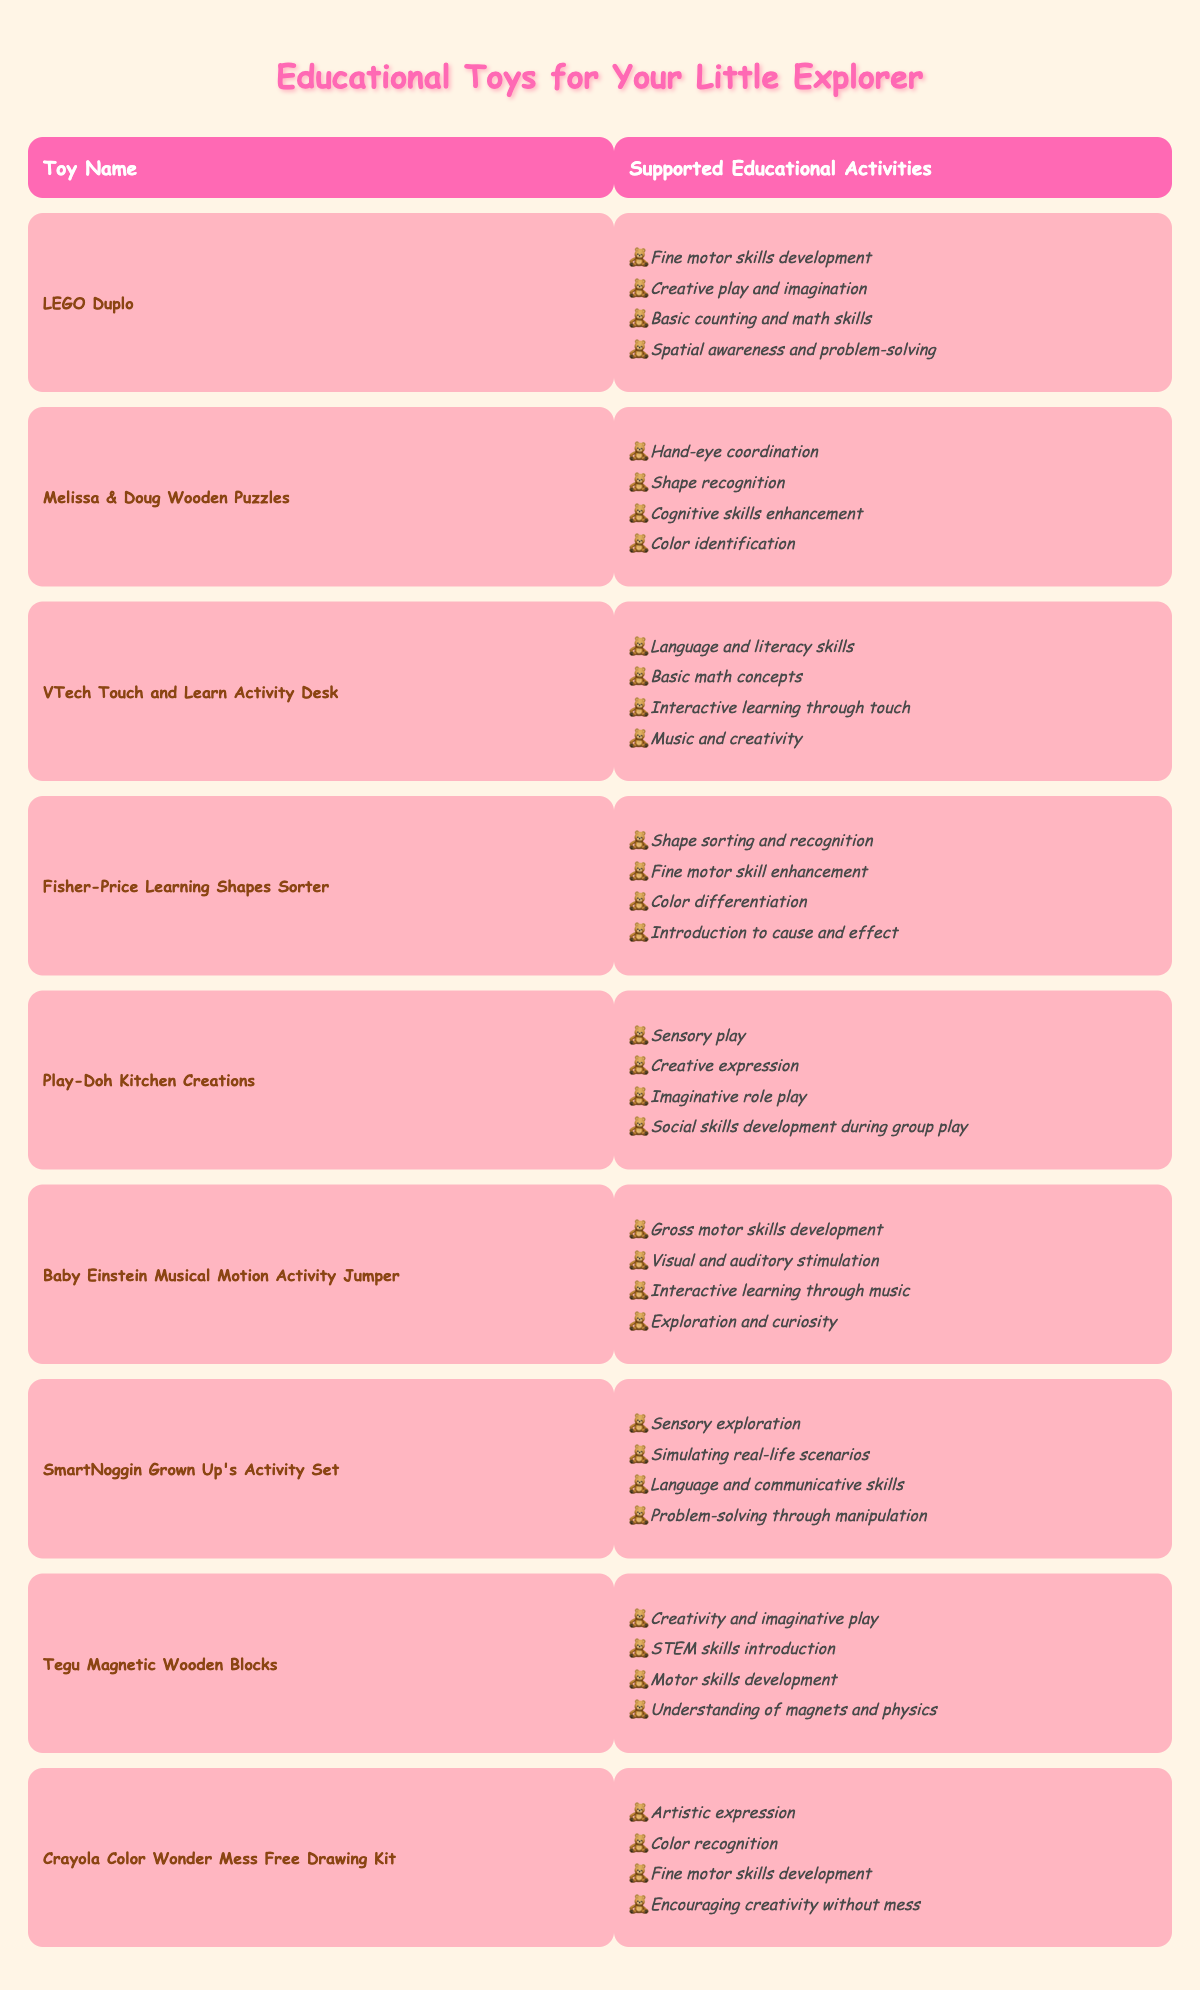What educational activity does LEGO Duplo support? LEGO Duplo supports various activities including fine motor skills development, creative play and imagination, basic counting and math skills, and spatial awareness and problem-solving. You can find these details in the supported activities section for LEGO Duplo in the table.
Answer: Fine motor skills development, creative play and imagination, basic counting and math skills, spatial awareness and problem-solving Which toy supports shape recognition? The toy that supports shape recognition is the Melissa & Doug Wooden Puzzles. This information is found in the supported activities section alongside the toy's name in the table.
Answer: Melissa & Doug Wooden Puzzles How many toys support gross motor skills development? The only toy that supports gross motor skills development is the Baby Einstein Musical Motion Activity Jumper, as listed in the table. Therefore, the total count is one.
Answer: 1 Does Play-Doh Kitchen Creations help develop social skills? Yes, Play-Doh Kitchen Creations supports social skills development during group play, according to the information provided in the supported activities column for this toy.
Answer: Yes Which toy has the most supported educational activities? To find the toy with the most supported activities, we count the number of activities for each toy. All toys in the table support four activities except the Baby Einstein Musical Motion Activity Jumper and SmartNoggin Grown Up's Activity Set, which also support four activities each. Therefore, several toys tie for the most supported activities, which is four.
Answer: Multiple toys tie with four activities each What are the supported activities for VTech Touch and Learn Activity Desk? The VTech Touch and Learn Activity Desk supports four activities: language and literacy skills, basic math concepts, interactive learning through touch, and music and creativity. This information is directly listed under its corresponding section in the table.
Answer: Language and literacy skills, basic math concepts, interactive learning through touch, music and creativity How many toys support creative play? Both LEGO Duplo and Play-Doh Kitchen Creations support creative play. By checking the supported activities for each toy, you can find this information. Since there are two toys that mention creative play directly, the answer is two.
Answer: 2 Is understanding of magnets and physics supported by any toy? Yes, the Tegu Magnetic Wooden Blocks toy supports understanding of magnets and physics, as seen in its list of supported activities in the table.
Answer: Yes Which toys help with fine motor skills development? The toys that help with fine motor skills development are LEGO Duplo, Fisher-Price Learning Shapes Sorter, Baby Einstein Musical Motion Activity Jumper, Crayola Color Wonder Mess Free Drawing Kit, and Melissa & Doug Wooden Puzzles. From the table, you can identify that five toys mention fine motor skills in their supported activities.
Answer: 5 Compare the number of toys that enhance cognitive skills to those that promote language skills. There are two toys that enhance cognitive skills (Melissa & Doug Wooden Puzzles and SmartNoggin Grown Up's Activity Set) and three that promote language skills (VTech Touch and Learn Activity Desk, SmartNoggin Grown Up's Activity Set, Baby Einstein Musical Motion Activity Jumper). Therefore, three toys promote language skills while two enhance cognitive skills, with language skills having one more than cognitive skills.
Answer: Language skills: 3, Cognitive skills: 2; difference is 1 Which toy provides the least amount of educational activities? All toys except the 'Crayola Color Wonder Mess Free Drawing Kit' and 'Fisher-Price Learning Shapes Sorter' support the same amount of educational activities. Hence, the answer is that all toys have four supported activities except the two mentioned, which have fewer.
Answer: Equal lower count from specific toys based on criteria 